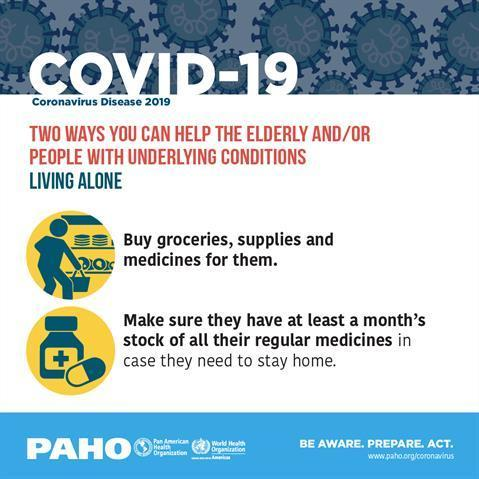Who are the ones that need assistance with purchasing and stocking?
Answer the question with a short phrase. The elderly and/or people with underlying conditions living alone What commodities need to be purchased for those living alone? Groceries, supplies and medicines What should be stockpiled for at least a month? Regular medicines 